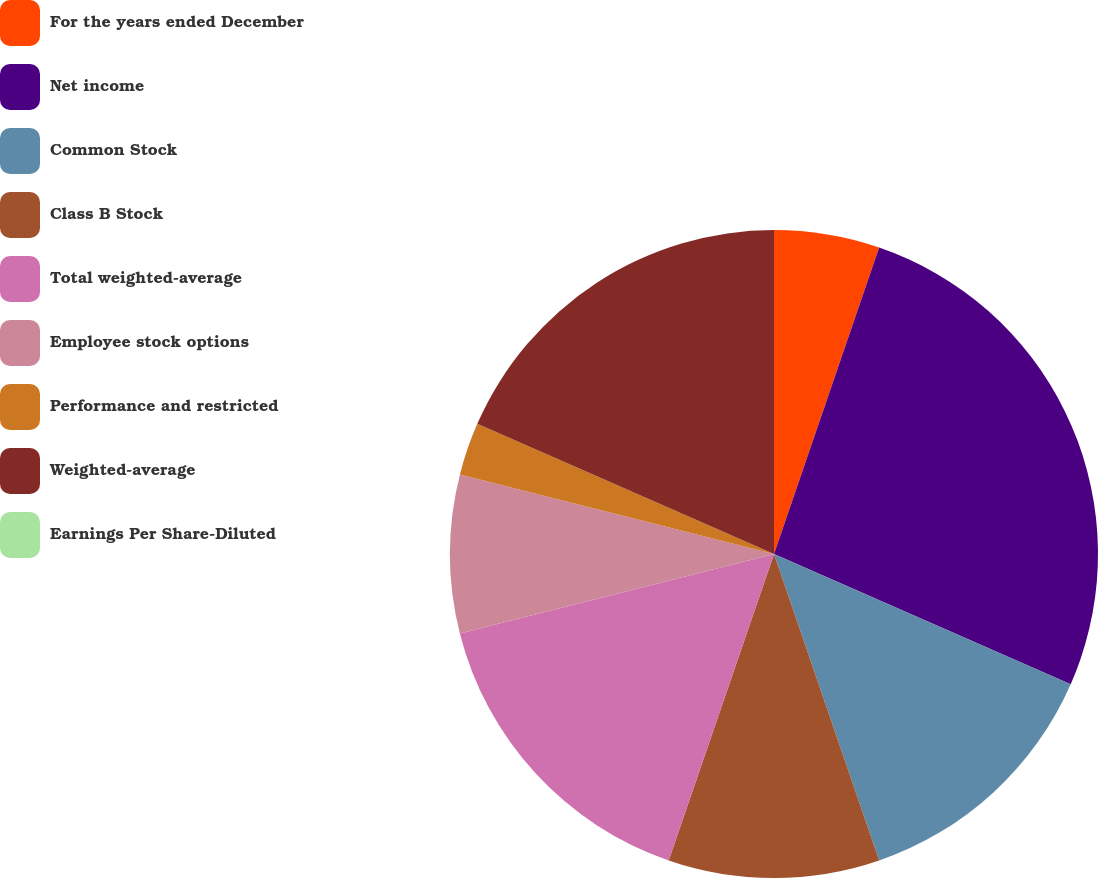Convert chart. <chart><loc_0><loc_0><loc_500><loc_500><pie_chart><fcel>For the years ended December<fcel>Net income<fcel>Common Stock<fcel>Class B Stock<fcel>Total weighted-average<fcel>Employee stock options<fcel>Performance and restricted<fcel>Weighted-average<fcel>Earnings Per Share-Diluted<nl><fcel>5.26%<fcel>26.32%<fcel>13.16%<fcel>10.53%<fcel>15.79%<fcel>7.89%<fcel>2.63%<fcel>18.42%<fcel>0.0%<nl></chart> 